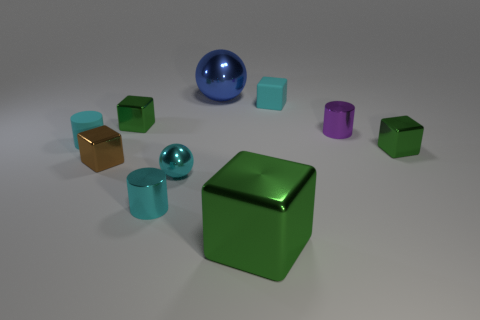Subtract all green blocks. How many were subtracted if there are1green blocks left? 2 Subtract all shiny cubes. How many cubes are left? 1 Subtract all purple cylinders. How many cylinders are left? 2 Subtract 5 blocks. How many blocks are left? 0 Subtract all balls. How many objects are left? 8 Add 1 rubber cylinders. How many rubber cylinders exist? 2 Subtract 0 brown spheres. How many objects are left? 10 Subtract all brown cubes. Subtract all purple balls. How many cubes are left? 4 Subtract all green spheres. How many gray cylinders are left? 0 Subtract all tiny gray metallic balls. Subtract all small metal objects. How many objects are left? 4 